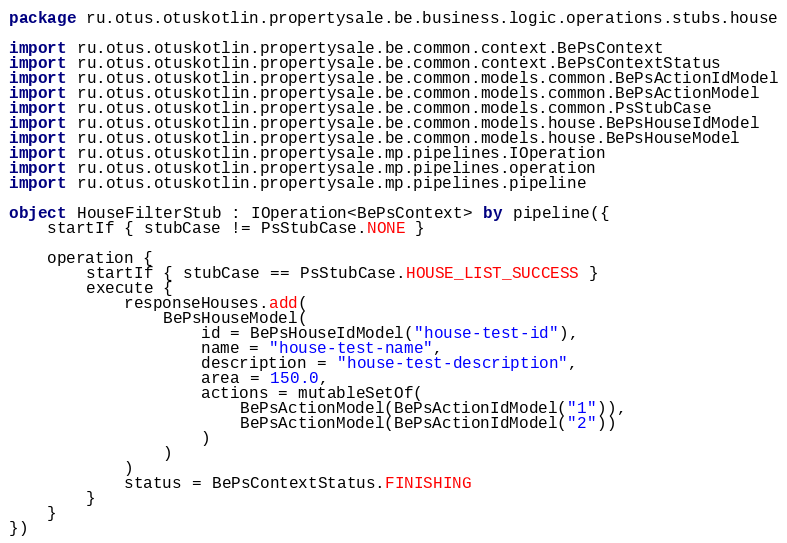Convert code to text. <code><loc_0><loc_0><loc_500><loc_500><_Kotlin_>package ru.otus.otuskotlin.propertysale.be.business.logic.operations.stubs.house

import ru.otus.otuskotlin.propertysale.be.common.context.BePsContext
import ru.otus.otuskotlin.propertysale.be.common.context.BePsContextStatus
import ru.otus.otuskotlin.propertysale.be.common.models.common.BePsActionIdModel
import ru.otus.otuskotlin.propertysale.be.common.models.common.BePsActionModel
import ru.otus.otuskotlin.propertysale.be.common.models.common.PsStubCase
import ru.otus.otuskotlin.propertysale.be.common.models.house.BePsHouseIdModel
import ru.otus.otuskotlin.propertysale.be.common.models.house.BePsHouseModel
import ru.otus.otuskotlin.propertysale.mp.pipelines.IOperation
import ru.otus.otuskotlin.propertysale.mp.pipelines.operation
import ru.otus.otuskotlin.propertysale.mp.pipelines.pipeline

object HouseFilterStub : IOperation<BePsContext> by pipeline({
    startIf { stubCase != PsStubCase.NONE }

    operation {
        startIf { stubCase == PsStubCase.HOUSE_LIST_SUCCESS }
        execute {
            responseHouses.add(
                BePsHouseModel(
                    id = BePsHouseIdModel("house-test-id"),
                    name = "house-test-name",
                    description = "house-test-description",
                    area = 150.0,
                    actions = mutableSetOf(
                        BePsActionModel(BePsActionIdModel("1")),
                        BePsActionModel(BePsActionIdModel("2"))
                    )
                )
            )
            status = BePsContextStatus.FINISHING
        }
    }
})
</code> 